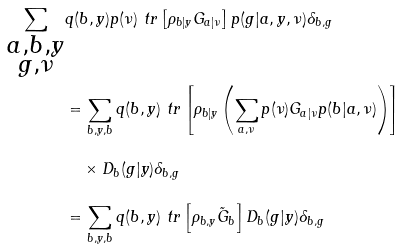<formula> <loc_0><loc_0><loc_500><loc_500>\sum _ { \substack { a , b , y \\ g , \nu } } & q ( b , y ) p ( \nu ) \ t r \left [ \rho _ { b | y } G _ { a | \nu } \right ] p ( g | a , y , \nu ) \delta _ { b , g } \\ & = \sum _ { b , y , b } q ( b , y ) \ t r \left [ \rho _ { b | y } \left ( \sum _ { a , \nu } p ( \nu ) G _ { a | \nu } p ( b | a , \nu ) \right ) \right ] \\ & \quad \times D _ { b } ( g | y ) \delta _ { b , g } \\ & = \sum _ { b , y , b } q ( b , y ) \ t r \left [ \rho _ { b , y } \tilde { G } _ { b } \right ] D _ { b } ( g | y ) \delta _ { b , g }</formula> 